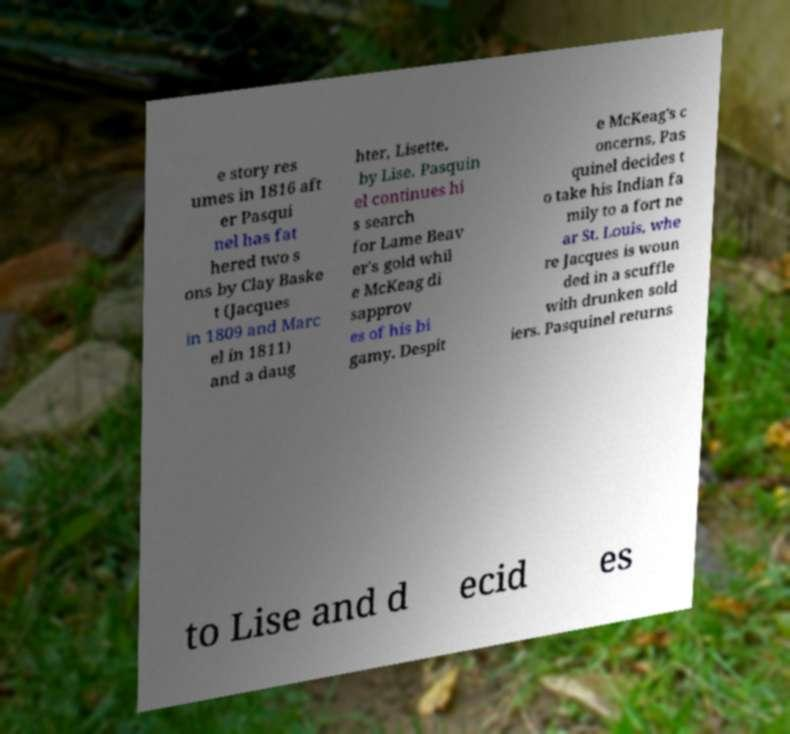Can you accurately transcribe the text from the provided image for me? e story res umes in 1816 aft er Pasqui nel has fat hered two s ons by Clay Baske t (Jacques in 1809 and Marc el in 1811) and a daug hter, Lisette, by Lise. Pasquin el continues hi s search for Lame Beav er's gold whil e McKeag di sapprov es of his bi gamy. Despit e McKeag's c oncerns, Pas quinel decides t o take his Indian fa mily to a fort ne ar St. Louis, whe re Jacques is woun ded in a scuffle with drunken sold iers. Pasquinel returns to Lise and d ecid es 